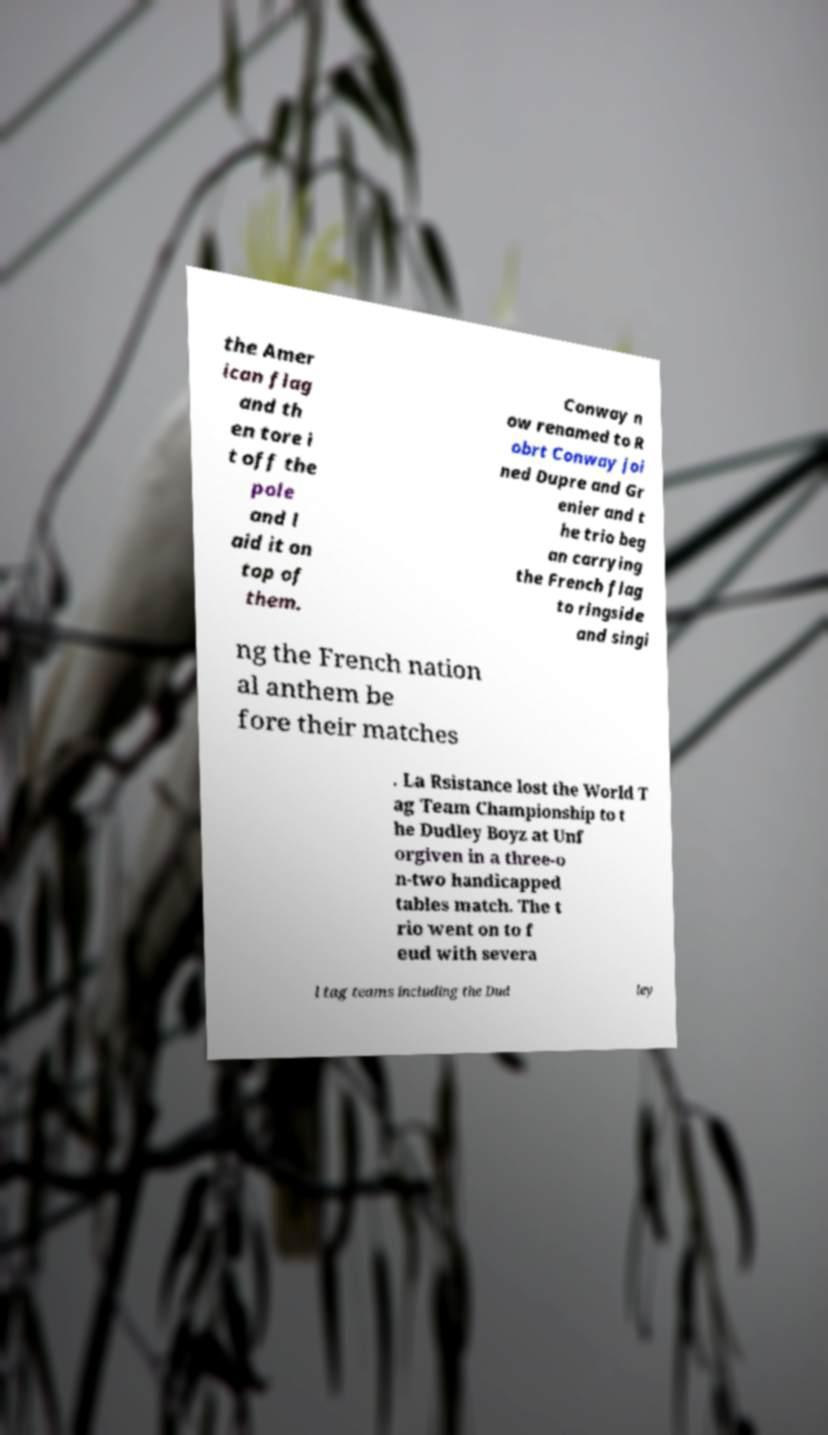Can you accurately transcribe the text from the provided image for me? the Amer ican flag and th en tore i t off the pole and l aid it on top of them. Conway n ow renamed to R obrt Conway joi ned Dupre and Gr enier and t he trio beg an carrying the French flag to ringside and singi ng the French nation al anthem be fore their matches . La Rsistance lost the World T ag Team Championship to t he Dudley Boyz at Unf orgiven in a three-o n-two handicapped tables match. The t rio went on to f eud with severa l tag teams including the Dud ley 